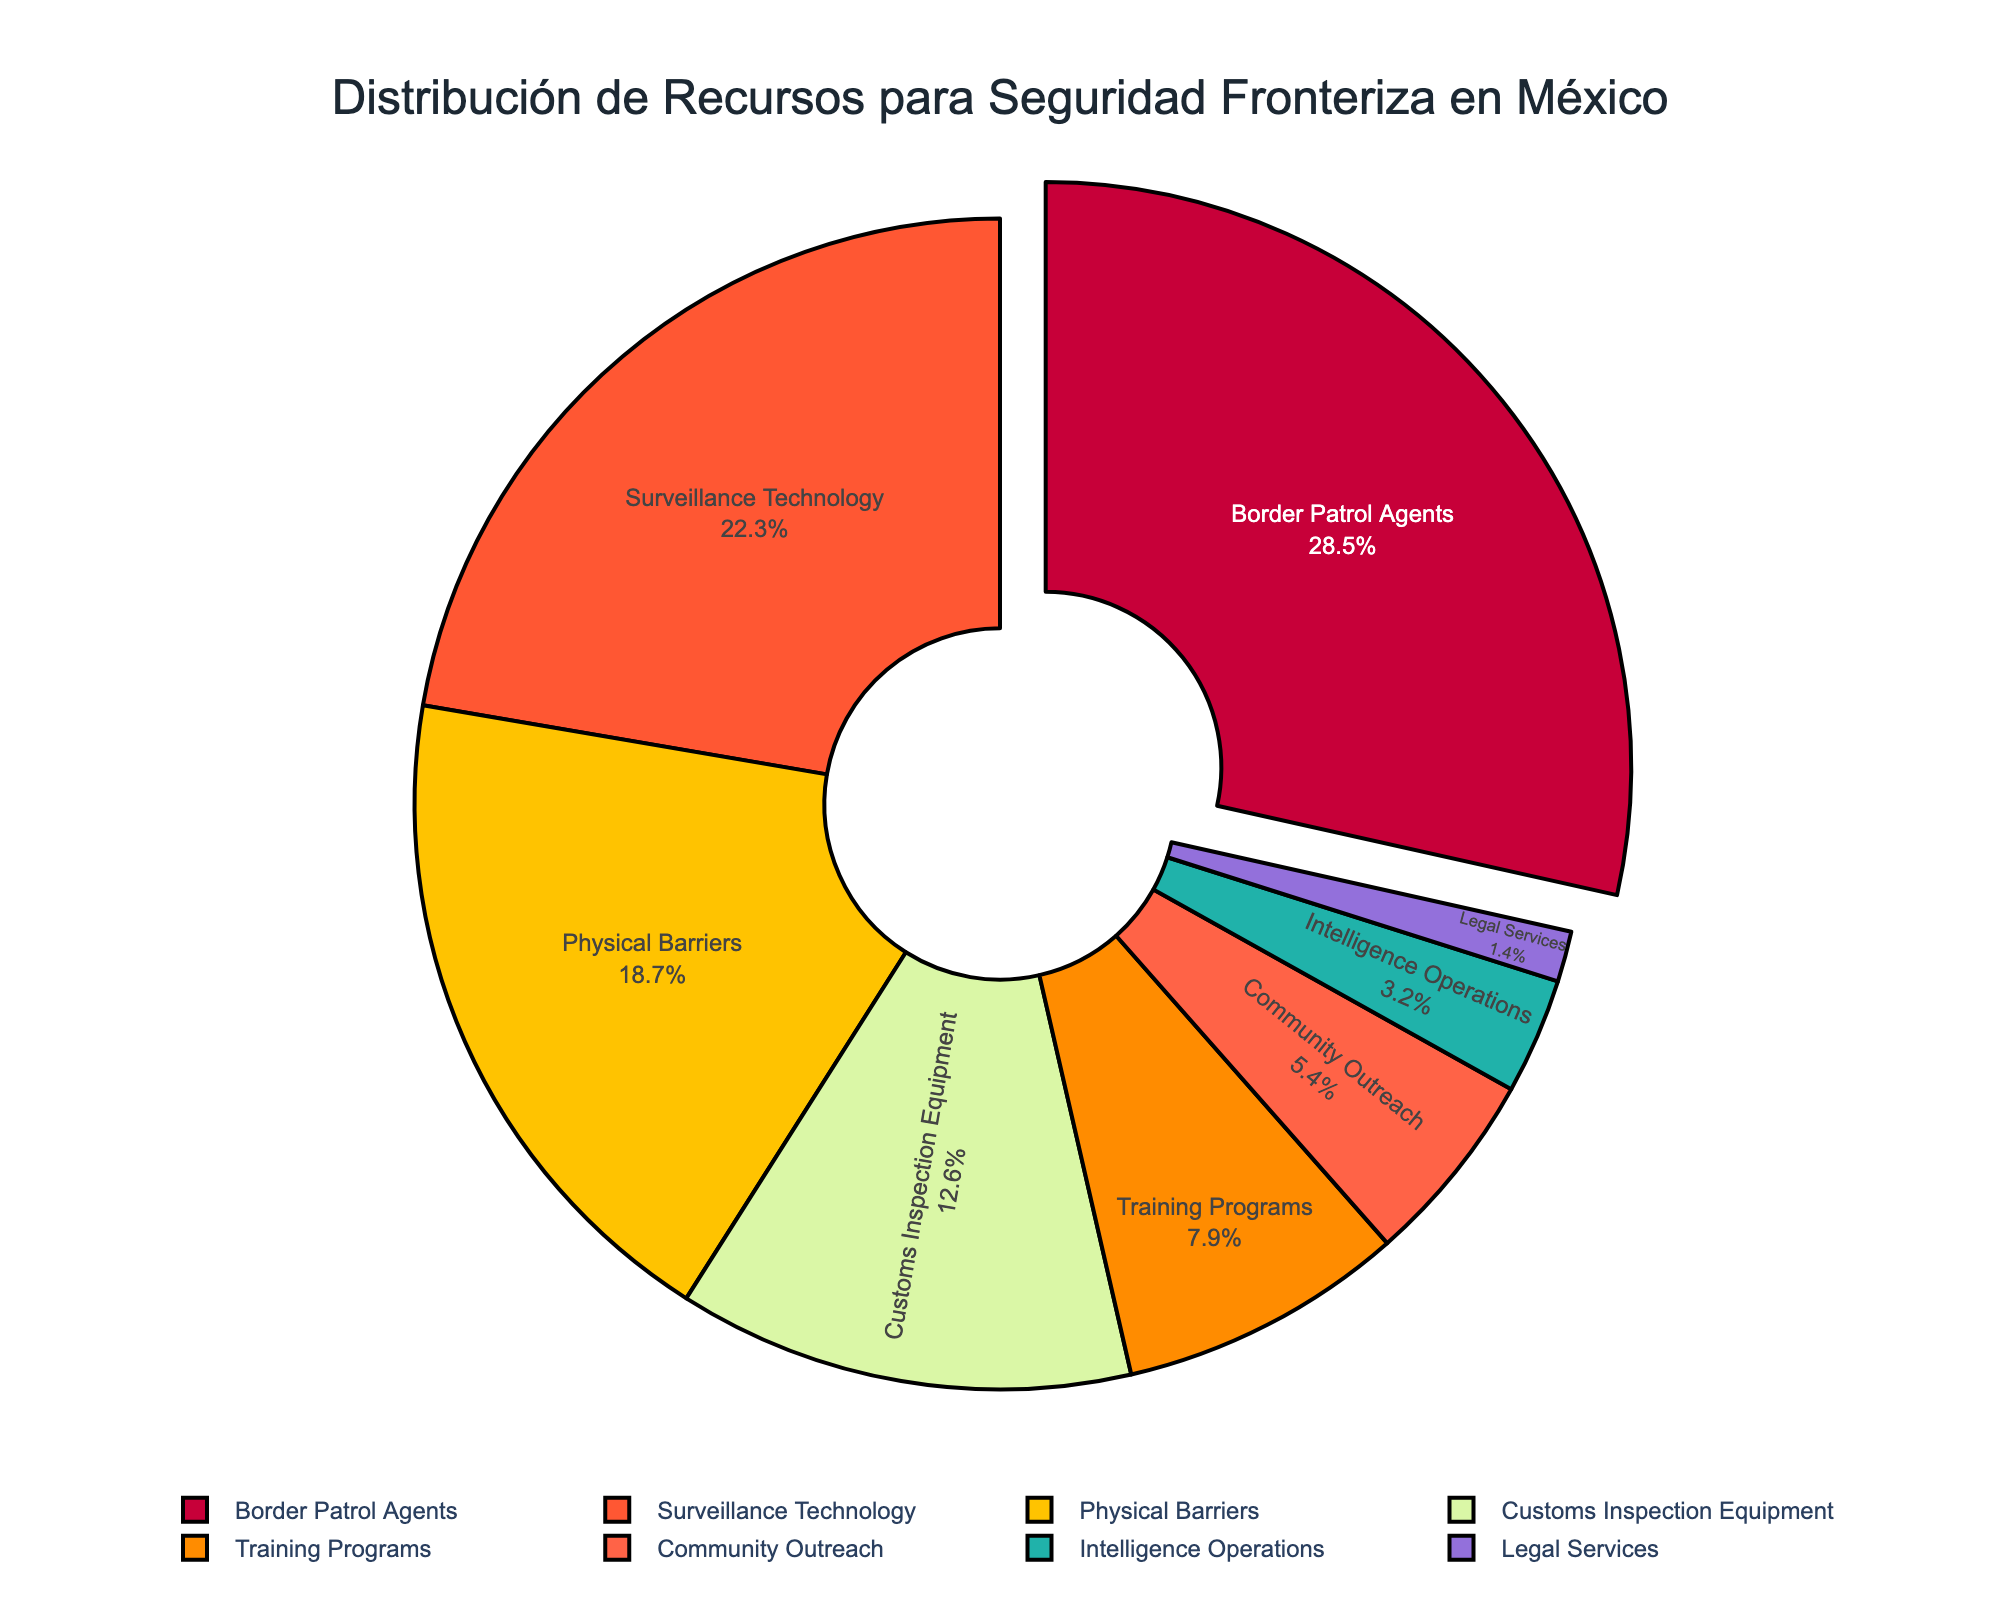What's the largest category in terms of percentage allocation? The largest category can be identified by noting which segment occupies the most space in the pie chart and is also pulled out slightly from the rest of the chart.
Answer: Border Patrol Agents Which two categories combined form a larger allocation than Border Patrol Agents alone? To determine this, add the percentages of various category pairs until you find a combination that exceeds the percentage allocation of Border Patrol Agents (28.5%). The pair Surveillance Technology (22.3%) and Physical Barriers (18.7%) together sum to 41%, which is greater than 28.5%.
Answer: Surveillance Technology and Physical Barriers What is the smallest category in terms of percentage allocation? The smallest category can be identified by finding the segment that occupies the least space in the pie chart.
Answer: Legal Services How much more allocation does Community Outreach receive compared to Intelligence Operations? Subtract the percentage allocation of Intelligence Operations (3.2%) from that of Community Outreach (5.4%). 5.4% - 3.2% = 2.2%.
Answer: 2.2% List all categories that receive less than 10% of the resources. Categories that receive less than 10% can be found by looking at the figures and identifying those with a percentage below 10%. These are: Training Programs (7.9%), Community Outreach (5.4%), Intelligence Operations (3.2%), and Legal Services (1.4%).
Answer: Training Programs, Community Outreach, Intelligence Operations, Legal Services Which categories are allocated more resources than Customs Inspection Equipment? Compare the percentages of all other categories to that of Customs Inspection Equipment (12.6%). The categories with higher percentages are Border Patrol Agents (28.5%), Surveillance Technology (22.3%), and Physical Barriers (18.7%).
Answer: Border Patrol Agents, Surveillance Technology, Physical Barriers Do Surveillance Technology and Training Programs together receive more resources than Physical Barriers? Add the percentages of Surveillance Technology (22.3%) and Training Programs (7.9%). The sum is 22.3% + 7.9% = 30.2%, which is more than the percentage for Physical Barriers (18.7%).
Answer: Yes Is the allocation for Border Patrol Agents more than twice the allocation for Training Programs? Double the percentage allocation for Training Programs (7.9%) and compare it to the allocation for Border Patrol Agents (28.5%). 7.9% * 2 = 15.8%, which is less than 28.5%.
Answer: Yes Which segment is denoted by the green color? Identify the segment in green color in the pie chart.
Answer: Customs Inspection Equipment 